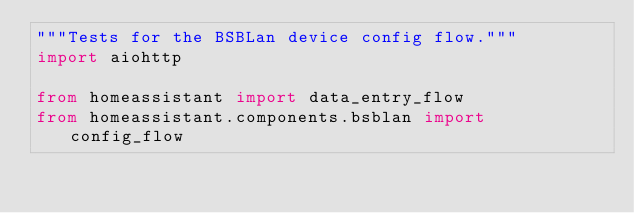Convert code to text. <code><loc_0><loc_0><loc_500><loc_500><_Python_>"""Tests for the BSBLan device config flow."""
import aiohttp

from homeassistant import data_entry_flow
from homeassistant.components.bsblan import config_flow</code> 